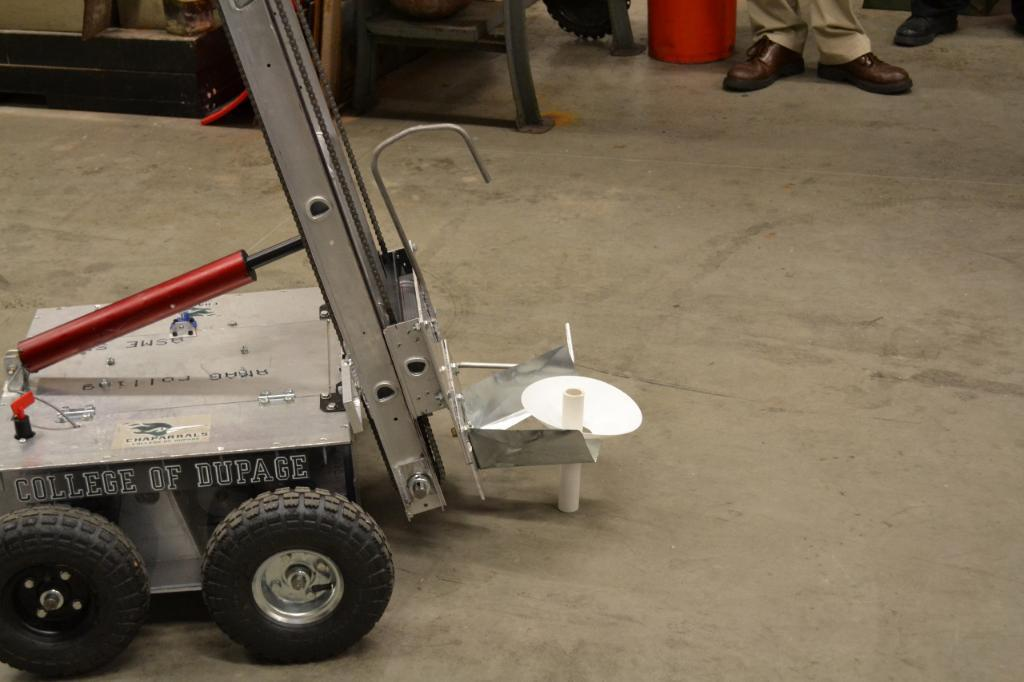What type of vehicle is present in the image? There is a vehicle with writing on it in the image. Can you describe any other details about the vehicle? Unfortunately, the facts provided do not give any additional details about the vehicle. What can be seen in the background of the image? There are person's legs visible in the background of the image. Are there any other objects or people visible in the image? Yes, there are other unspecified items in the image. What type of knowledge is being shared by the dirt in the image? There is no dirt present in the image, and therefore no knowledge can be shared by it. 